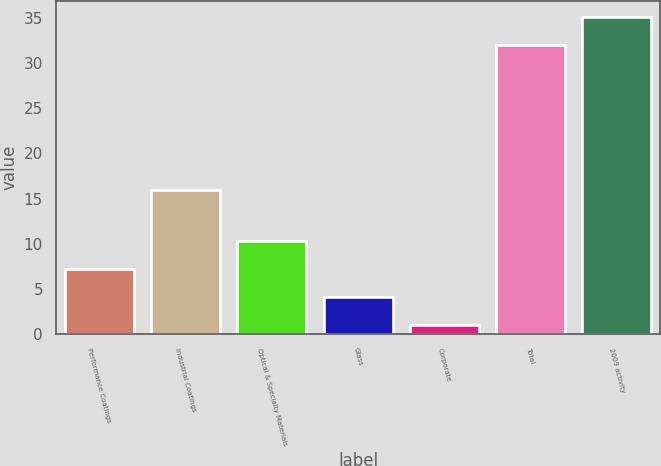Convert chart. <chart><loc_0><loc_0><loc_500><loc_500><bar_chart><fcel>Performance Coatings<fcel>Industrial Coatings<fcel>Optical & Specialty Materials<fcel>Glass<fcel>Corporate<fcel>Total<fcel>2009 activity<nl><fcel>7.2<fcel>16<fcel>10.3<fcel>4.1<fcel>1<fcel>32<fcel>35.1<nl></chart> 